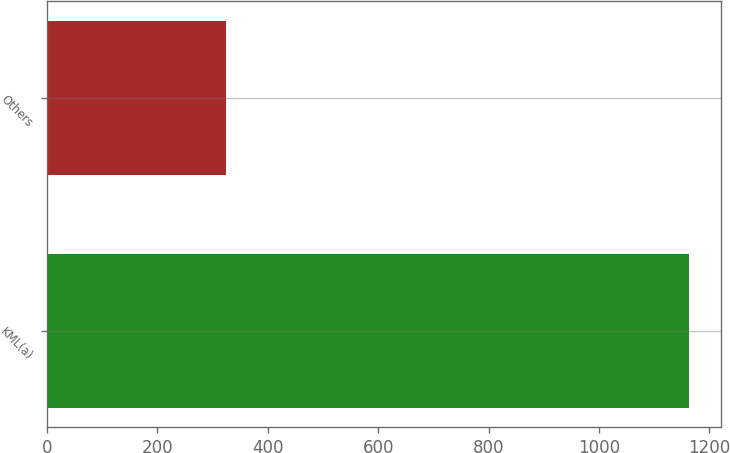<chart> <loc_0><loc_0><loc_500><loc_500><bar_chart><fcel>KML(a)<fcel>Others<nl><fcel>1163<fcel>325<nl></chart> 